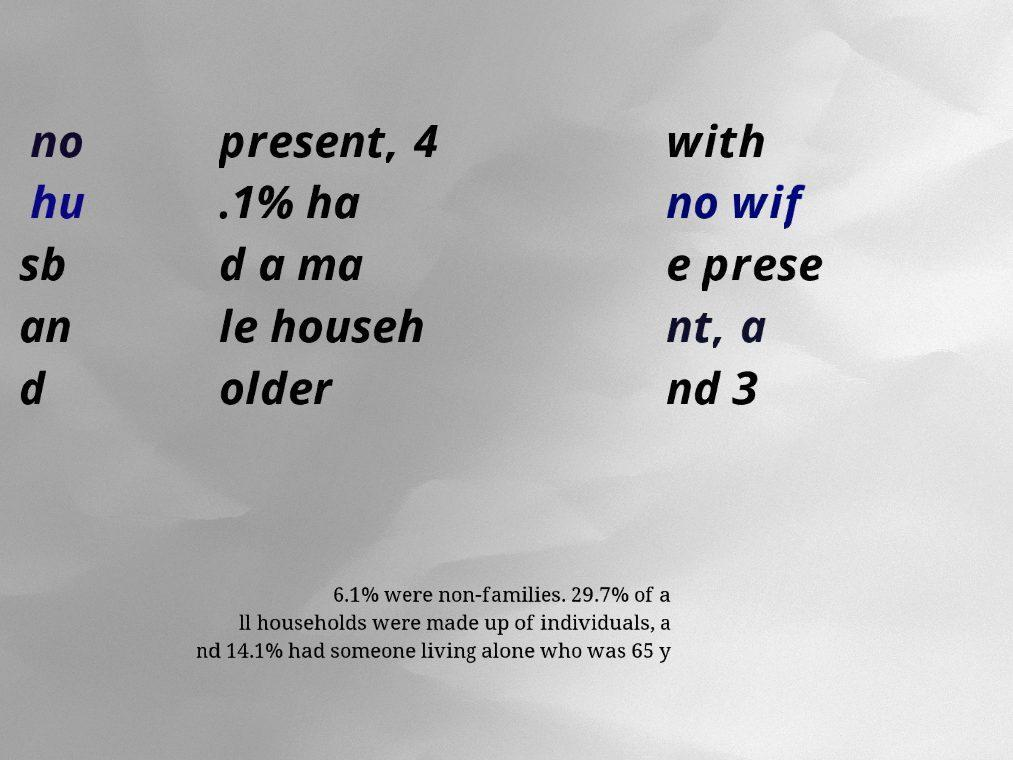For documentation purposes, I need the text within this image transcribed. Could you provide that? no hu sb an d present, 4 .1% ha d a ma le househ older with no wif e prese nt, a nd 3 6.1% were non-families. 29.7% of a ll households were made up of individuals, a nd 14.1% had someone living alone who was 65 y 